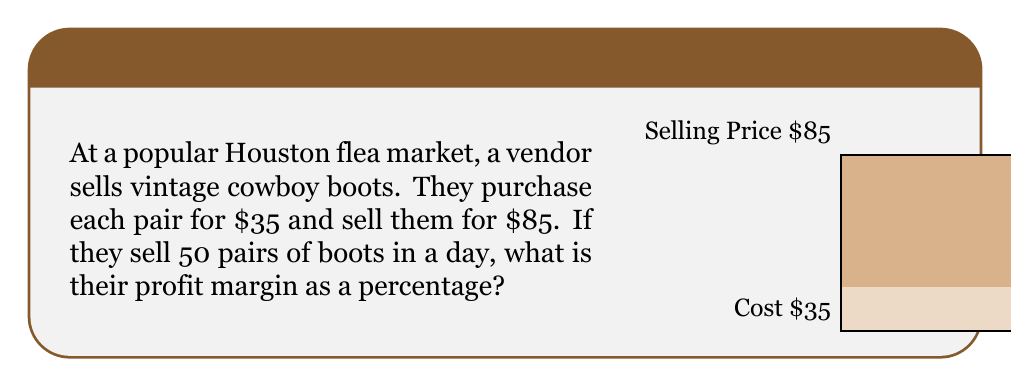Can you solve this math problem? Let's approach this step-by-step:

1) First, let's calculate the profit per pair of boots:
   Profit per pair = Selling price - Cost price
   $$ \text{Profit per pair} = $85 - $35 = $50 $$

2) Now, let's calculate the total profit for 50 pairs:
   $$ \text{Total profit} = $50 \times 50 = $2500 $$

3) The total revenue (selling price for all boots) is:
   $$ \text{Total revenue} = $85 \times 50 = $4250 $$

4) To calculate the profit margin as a percentage, we use the formula:
   $$ \text{Profit Margin} = \frac{\text{Total Profit}}{\text{Total Revenue}} \times 100\% $$

5) Plugging in our values:
   $$ \text{Profit Margin} = \frac{$2500}{$4250} \times 100\% $$

6) Simplifying:
   $$ \text{Profit Margin} = 0.5882 \times 100\% = 58.82\% $$

Therefore, the vendor's profit margin is approximately 58.82%.
Answer: 58.82% 